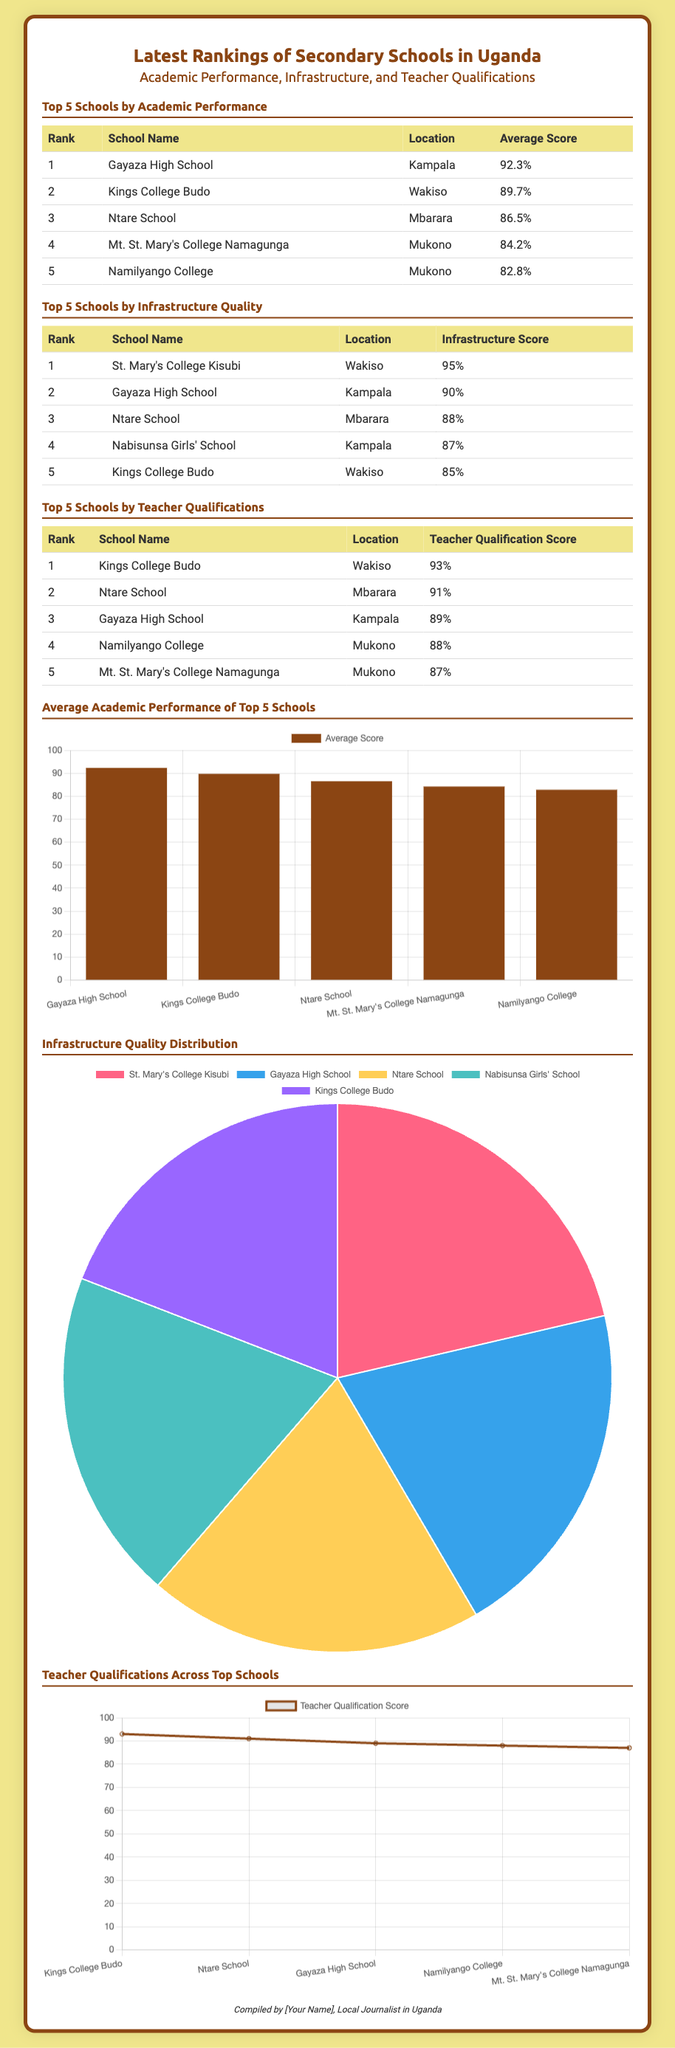What is the school with the highest average score? Gayaza High School has the highest average score of 92.3%.
Answer: Gayaza High School Which school has the highest infrastructure score? St. Mary's College Kisubi has the highest infrastructure score of 95%.
Answer: St. Mary's College Kisubi What is the average score of Namilyango College? Namilyango College has an average score of 82.8%.
Answer: 82.8% How many schools are listed in the teacher qualifications section? There are 5 schools listed in the teacher qualifications section.
Answer: 5 Which school ranked second in teacher qualifications? Kings College Budo ranked second in teacher qualifications with a score of 93%.
Answer: Kings College Budo What is the average score of the top-performing school in infrastructure? The average infrastructure score of St. Mary's College Kisubi is 95%.
Answer: 95% What type of chart is used to display the qualifications across top schools? A line chart is used to display teacher qualifications across top schools.
Answer: Line chart Which school is located in Mukono and is in the top 5 for academic performance? Namilyango College is located in Mukono and is in the top 5 for academic performance.
Answer: Namilyango College What is the average Teacher Qualification Score for Ntare School? Ntare School has a Teacher Qualification Score of 91%.
Answer: 91% 